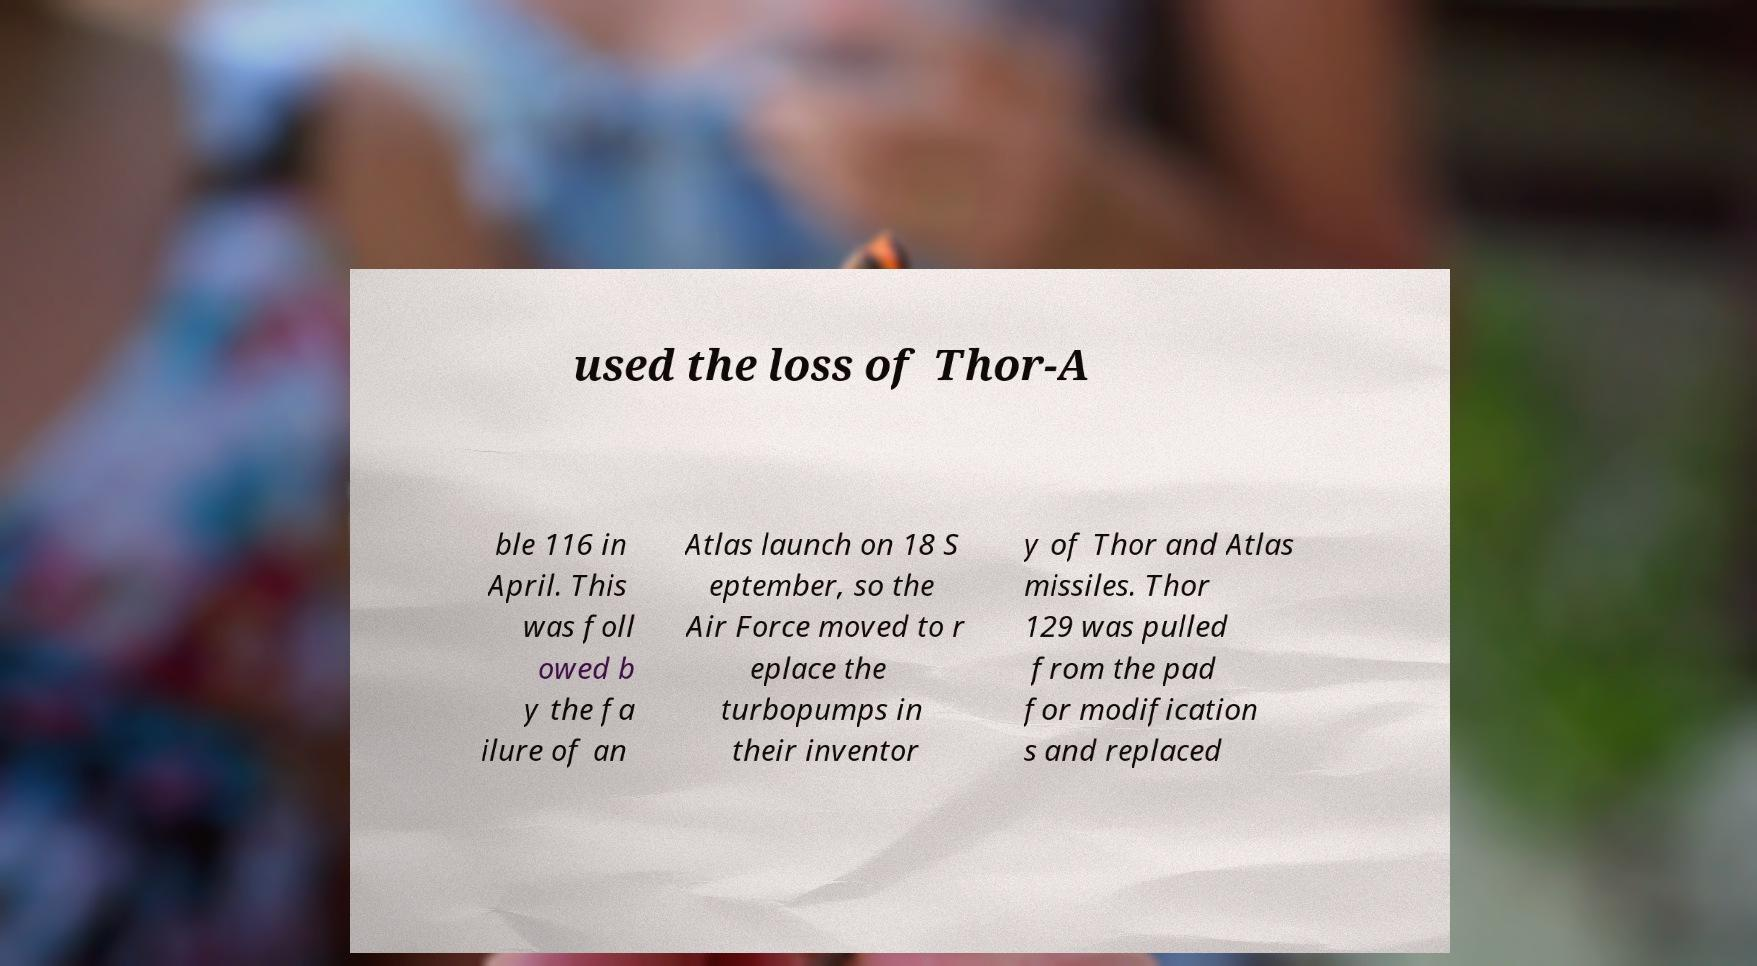I need the written content from this picture converted into text. Can you do that? used the loss of Thor-A ble 116 in April. This was foll owed b y the fa ilure of an Atlas launch on 18 S eptember, so the Air Force moved to r eplace the turbopumps in their inventor y of Thor and Atlas missiles. Thor 129 was pulled from the pad for modification s and replaced 